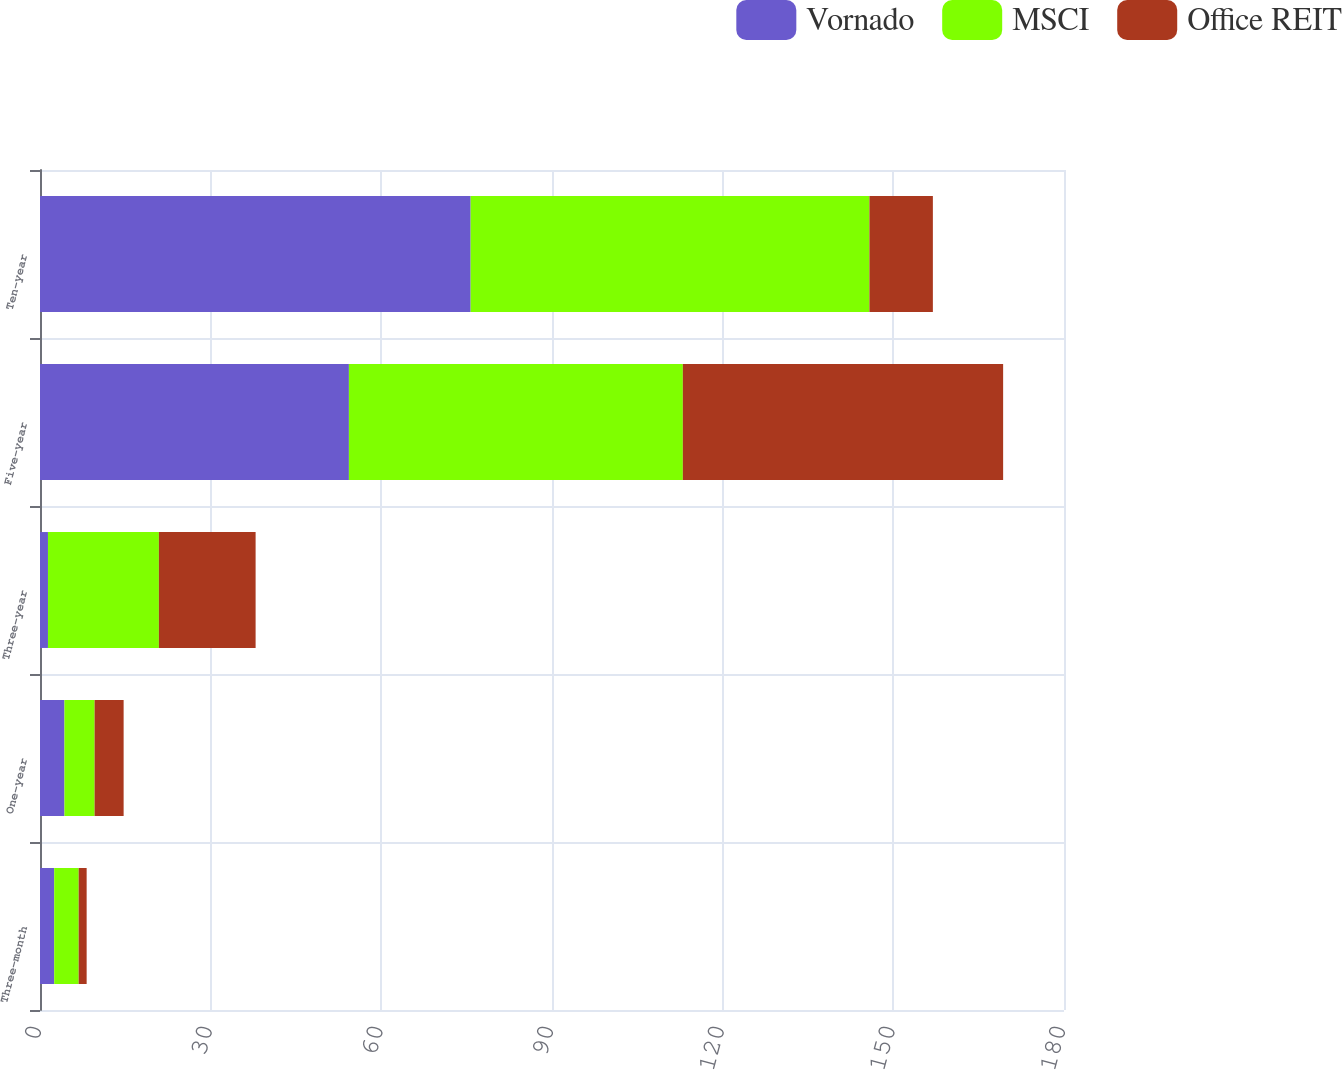Convert chart. <chart><loc_0><loc_0><loc_500><loc_500><stacked_bar_chart><ecel><fcel>Three-month<fcel>One-year<fcel>Three-year<fcel>Five-year<fcel>Ten-year<nl><fcel>Vornado<fcel>2.5<fcel>4.3<fcel>1.4<fcel>54.3<fcel>75.7<nl><fcel>MSCI<fcel>4.3<fcel>5.3<fcel>19.5<fcel>58.7<fcel>70.1<nl><fcel>Office REIT<fcel>1.4<fcel>5.1<fcel>17<fcel>56.3<fcel>11.15<nl></chart> 